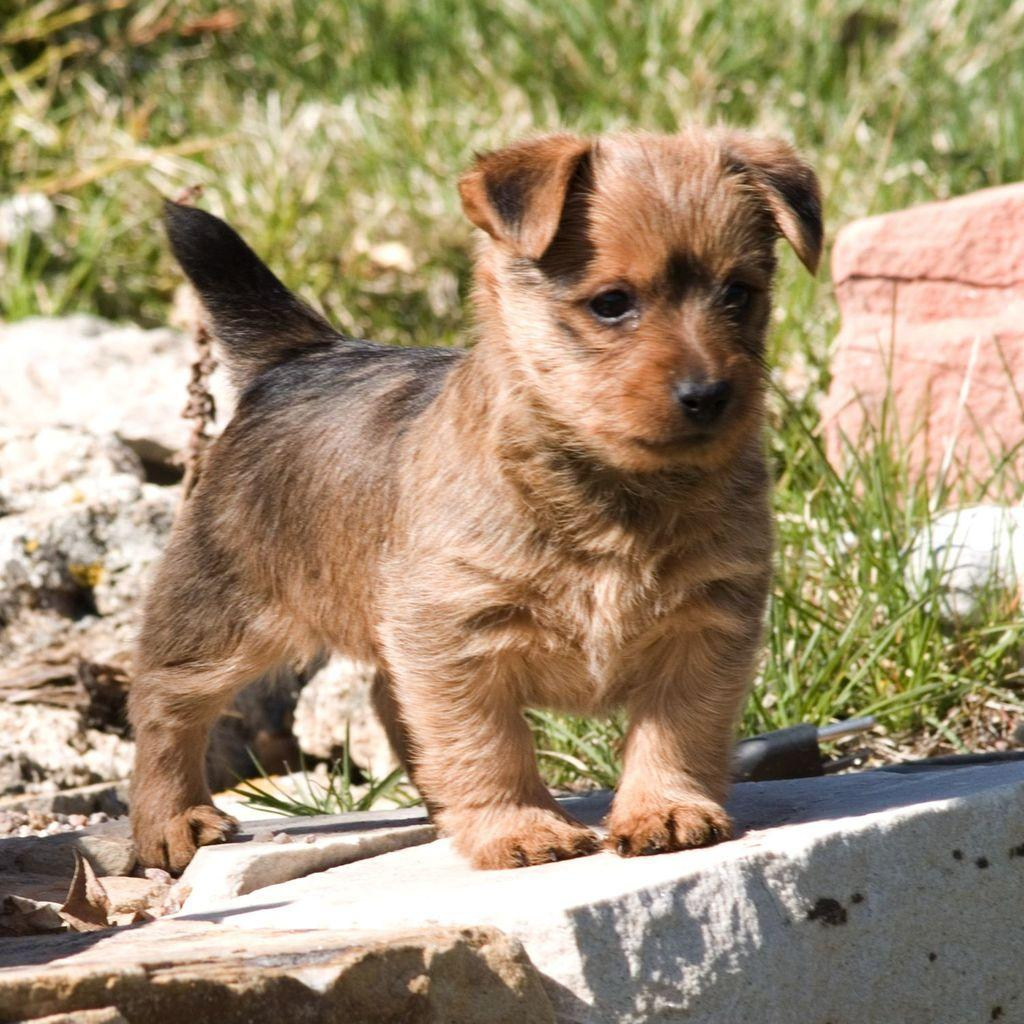What type of animal is in the image? There is a dog in the image. What is the dog standing on? The dog is standing on a stone. What can be seen in the background of the image? Grass is visible in the background of the image. Can you see the ghost playing with the dog in the image? There is no ghost present in the image; it only features a dog standing on a stone with grass visible in the background. 